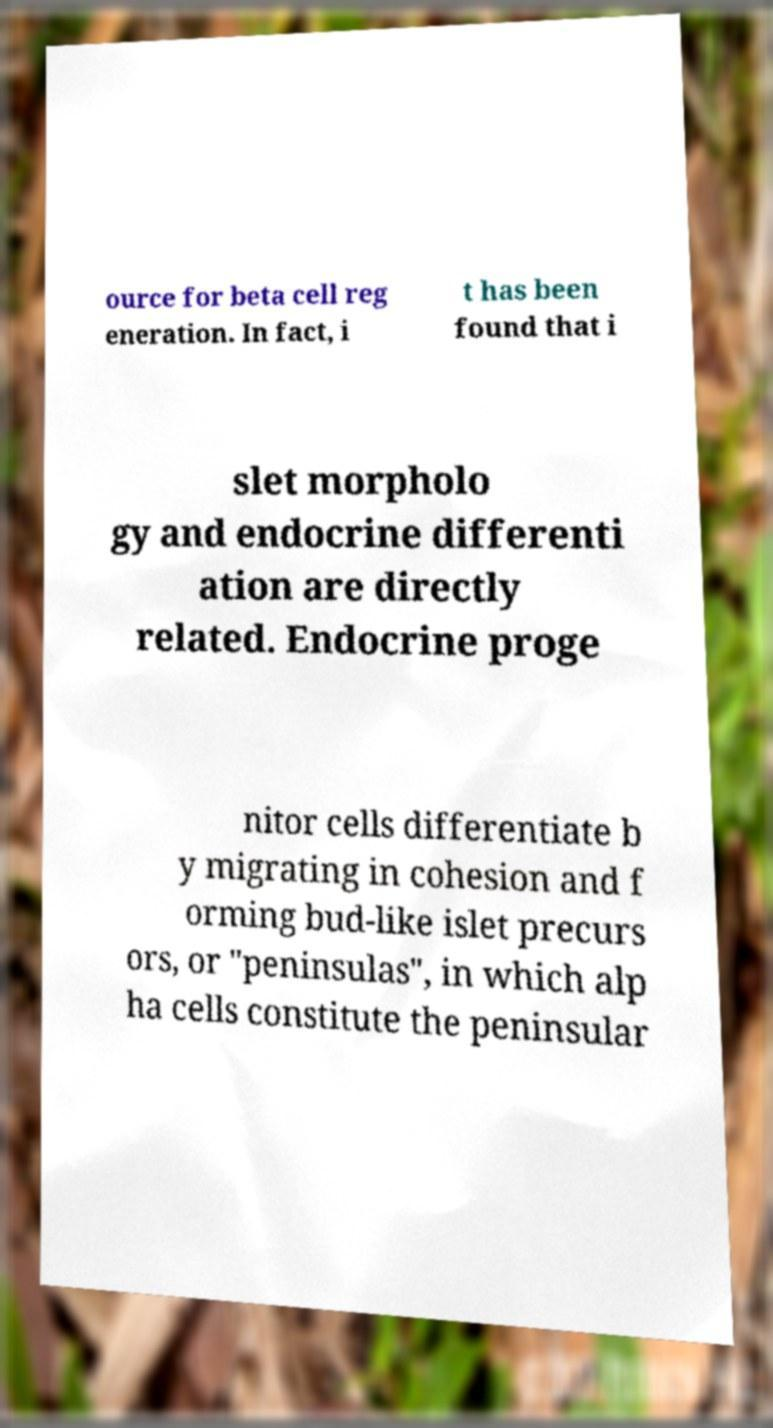Could you assist in decoding the text presented in this image and type it out clearly? ource for beta cell reg eneration. In fact, i t has been found that i slet morpholo gy and endocrine differenti ation are directly related. Endocrine proge nitor cells differentiate b y migrating in cohesion and f orming bud-like islet precurs ors, or "peninsulas", in which alp ha cells constitute the peninsular 